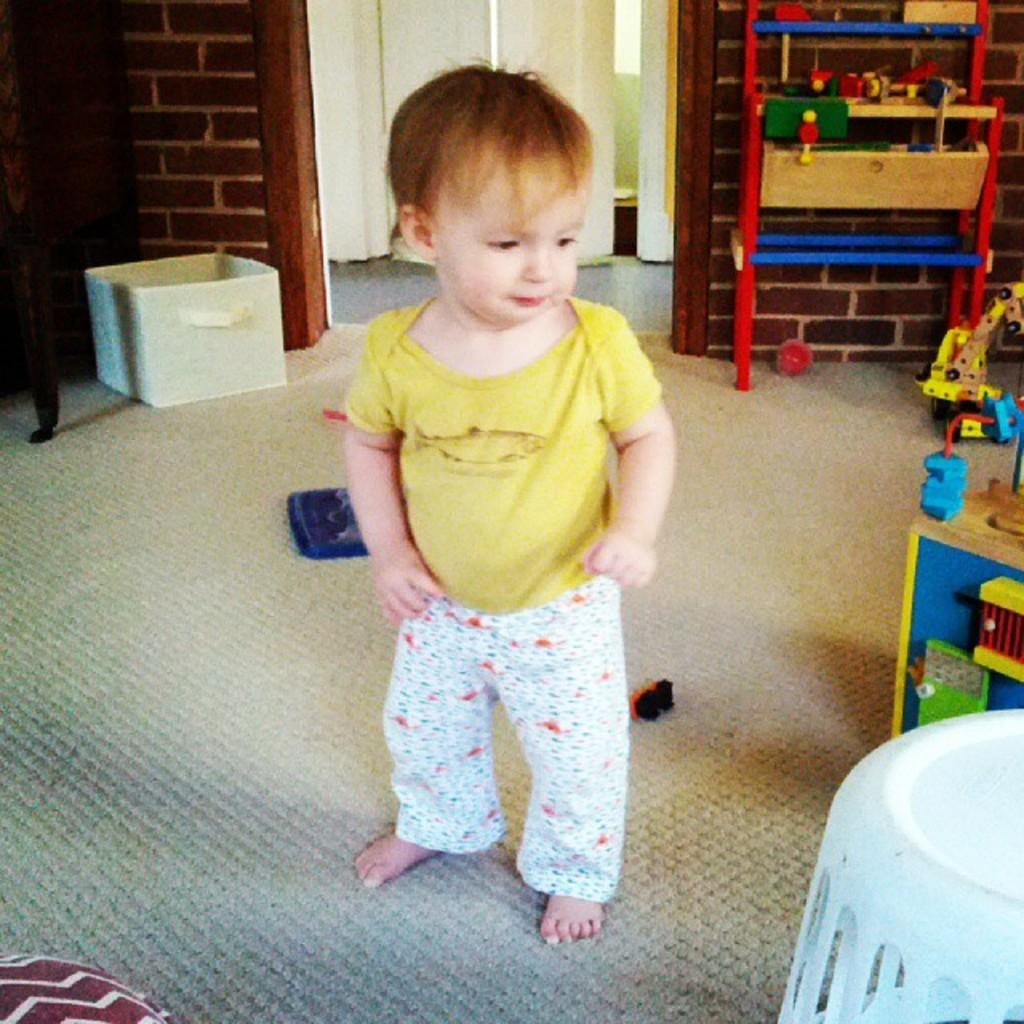What is the main subject of the image? There is a baby in the image. What is the baby wearing? The baby is wearing a yellow t-shirt and white pants. Where is the baby standing? The baby is standing on a carpet. What can be seen in the background of the image? There is a door in the background of the image. What else is on the floor besides the baby? There are toys on the floor. What is located on the left side of the image? There is a basket on the left side of the image. What type of animal can be seen playing with the baby in the image? There is no animal present in the image; it only features a baby, toys, and a basket. What system of organization is used for the toys in the image? There is no indication of a specific system of organization for the toys in the image. 